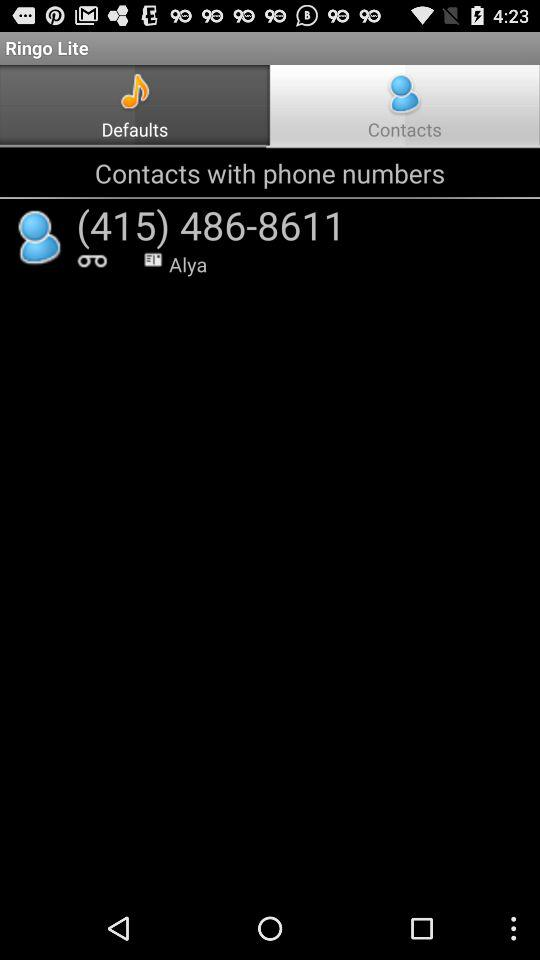What is the phone number? The phone number is (415) 486-8611. 